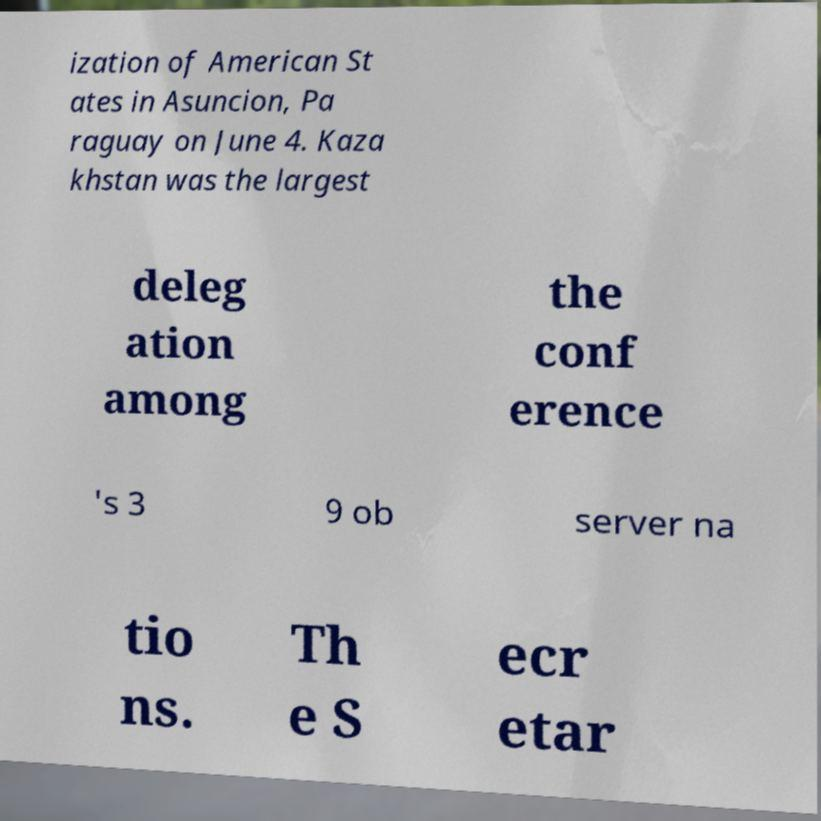Please read and relay the text visible in this image. What does it say? ization of American St ates in Asuncion, Pa raguay on June 4. Kaza khstan was the largest deleg ation among the conf erence 's 3 9 ob server na tio ns. Th e S ecr etar 